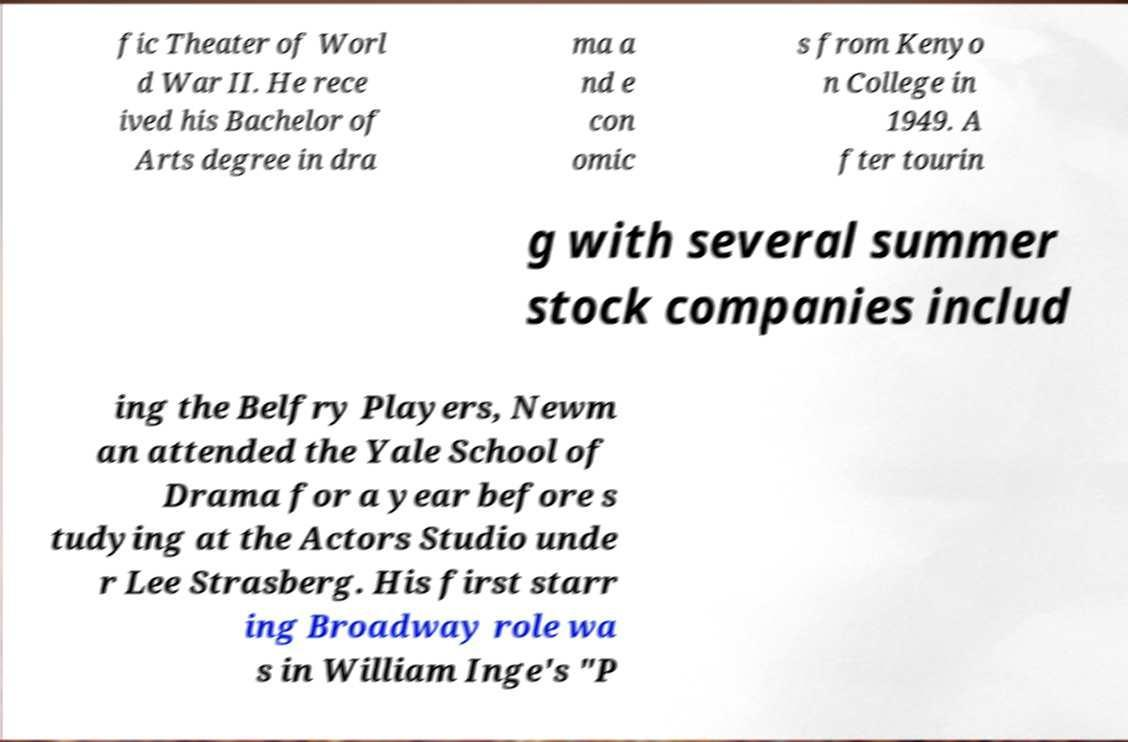Can you accurately transcribe the text from the provided image for me? fic Theater of Worl d War II. He rece ived his Bachelor of Arts degree in dra ma a nd e con omic s from Kenyo n College in 1949. A fter tourin g with several summer stock companies includ ing the Belfry Players, Newm an attended the Yale School of Drama for a year before s tudying at the Actors Studio unde r Lee Strasberg. His first starr ing Broadway role wa s in William Inge's "P 